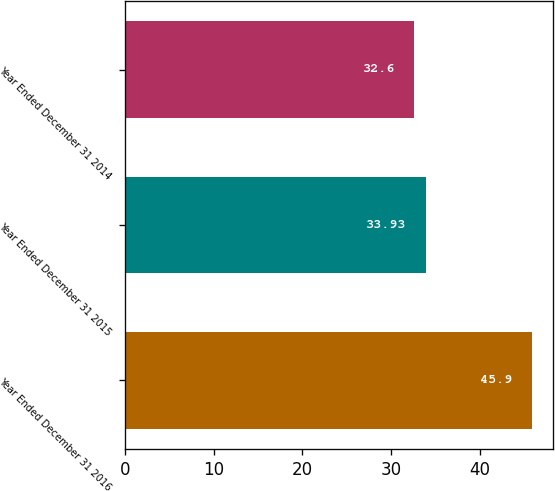Convert chart. <chart><loc_0><loc_0><loc_500><loc_500><bar_chart><fcel>Year Ended December 31 2016<fcel>Year Ended December 31 2015<fcel>Year Ended December 31 2014<nl><fcel>45.9<fcel>33.93<fcel>32.6<nl></chart> 